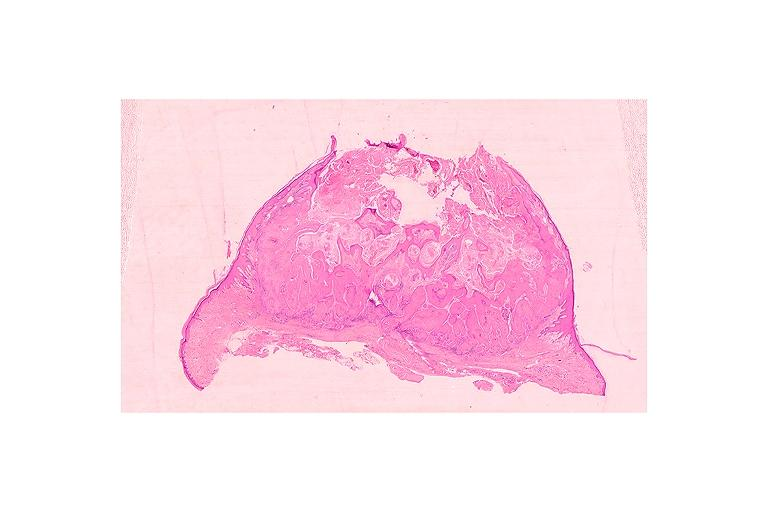s oral present?
Answer the question using a single word or phrase. Yes 